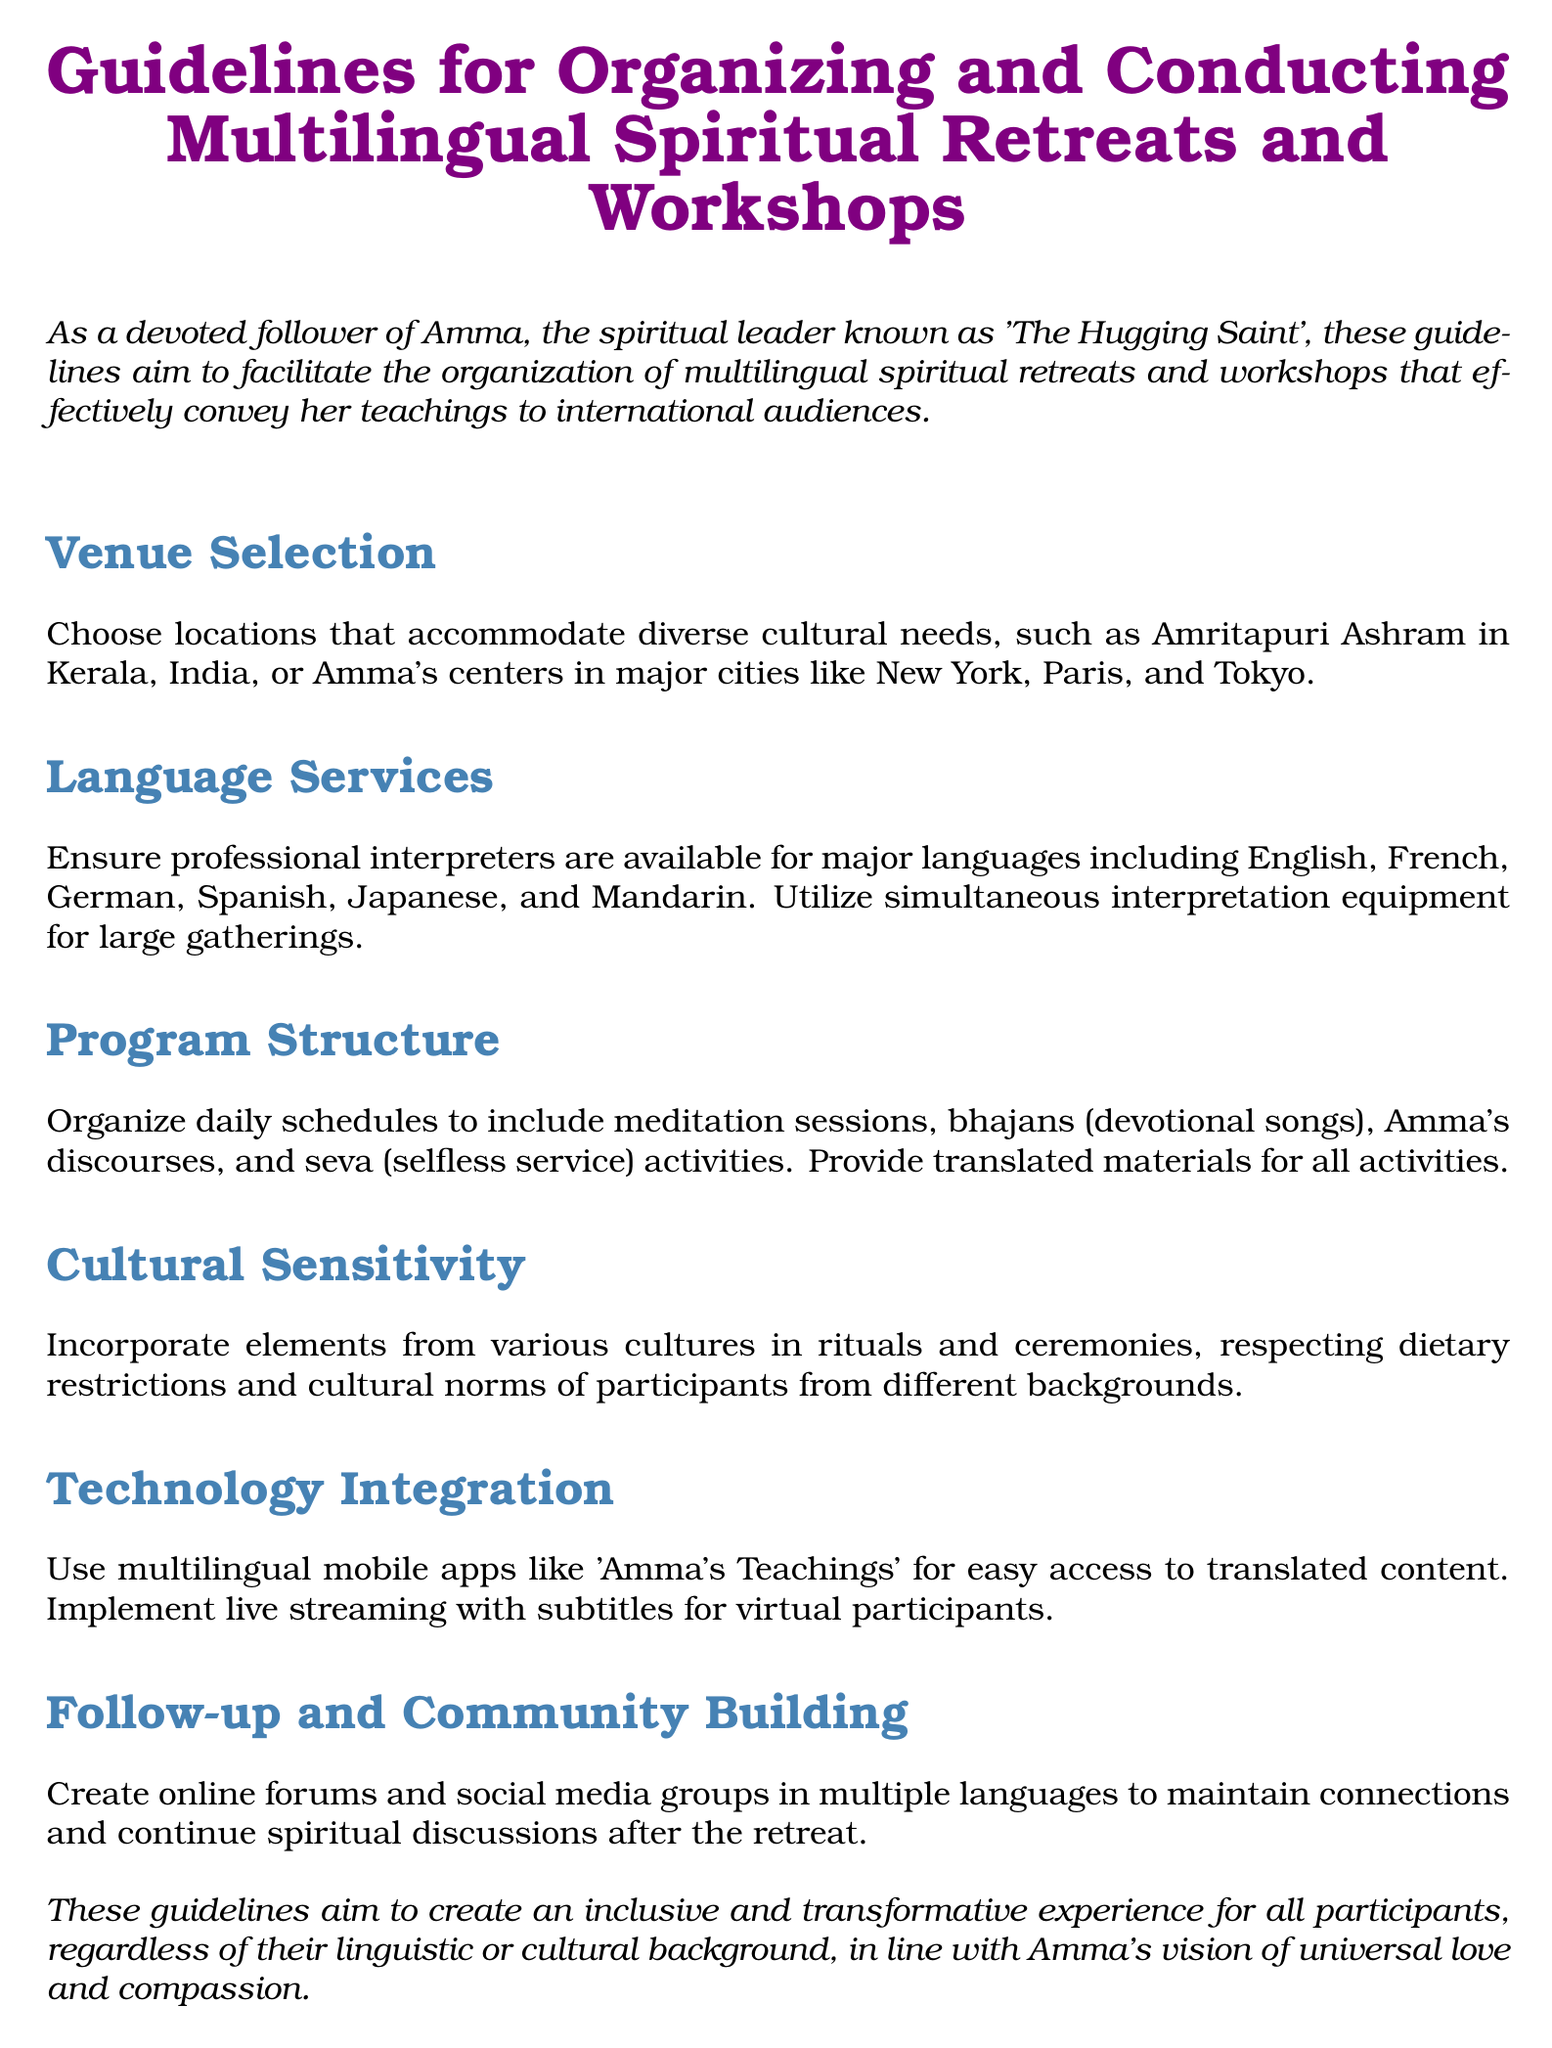What are examples of venues for retreats? The document lists Amritapuri Ashram in Kerala, India and Amma's centers in major cities like New York, Paris, and Tokyo as venue options.
Answer: Amritapuri Ashram, New York, Paris, Tokyo Which languages must professional interpreters be available for? The guidelines specify that interpreters should be available for major languages such as English, French, German, Spanish, Japanese, and Mandarin.
Answer: English, French, German, Spanish, Japanese, Mandarin What activities should be included in the program structure? The document mentions activities such as meditation sessions, bhajans, Amma's discourses, and seva activities as part of the program structure.
Answer: Meditation sessions, bhajans, discourses, seva What is the purpose of incorporating cultural elements? It aims to respect the dietary restrictions and cultural norms of participants from different backgrounds.
Answer: Respect cultural norms What technological tool is suggested for accessing translated content? The guidelines recommend using multilingual mobile apps like 'Amma's Teachings' for easier access to translated materials.
Answer: 'Amma's Teachings' What type of community connection is encouraged after the retreat? The document suggests creating online forums and social media groups in multiple languages to maintain connections and continue spiritual discussions.
Answer: Online forums, social media groups 